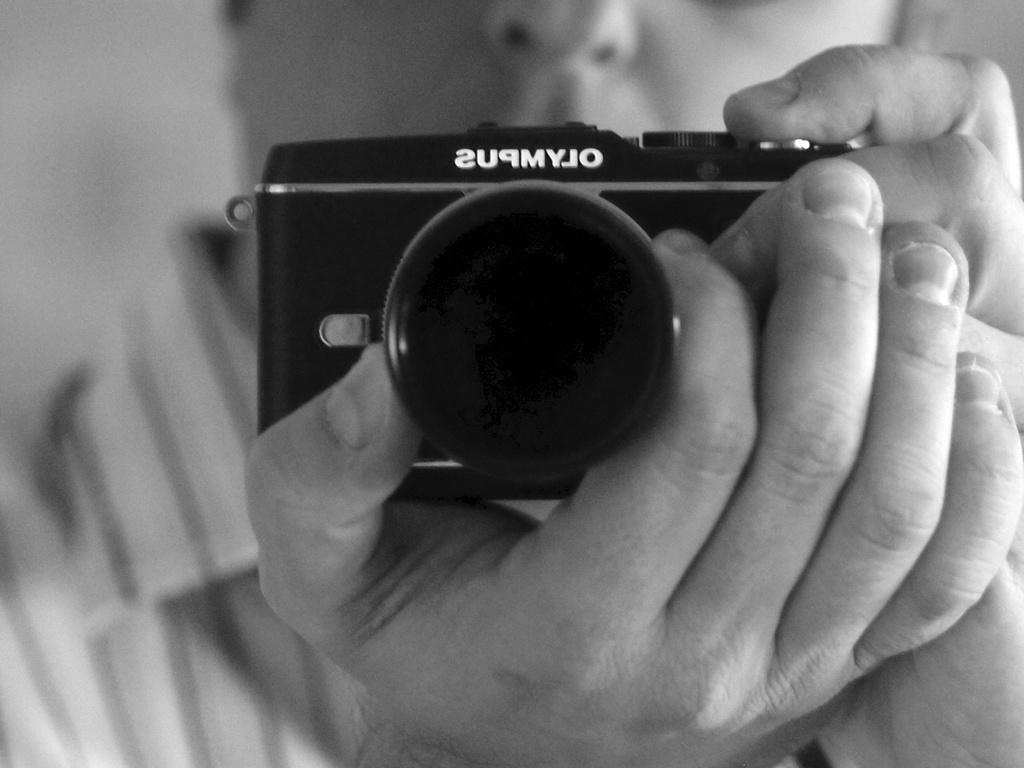What is the main subject of the image? There is a person in the center of the image. What is the person holding in the image? The person is holding a camera. What might the person be doing with the camera? The person appears to be taking pictures. Can you read any text on the camera? Yes, there is text visible on the camera. What type of snake can be seen slithering across the desk in the image? There is no snake or desk present in the image; it features a person holding a camera. 